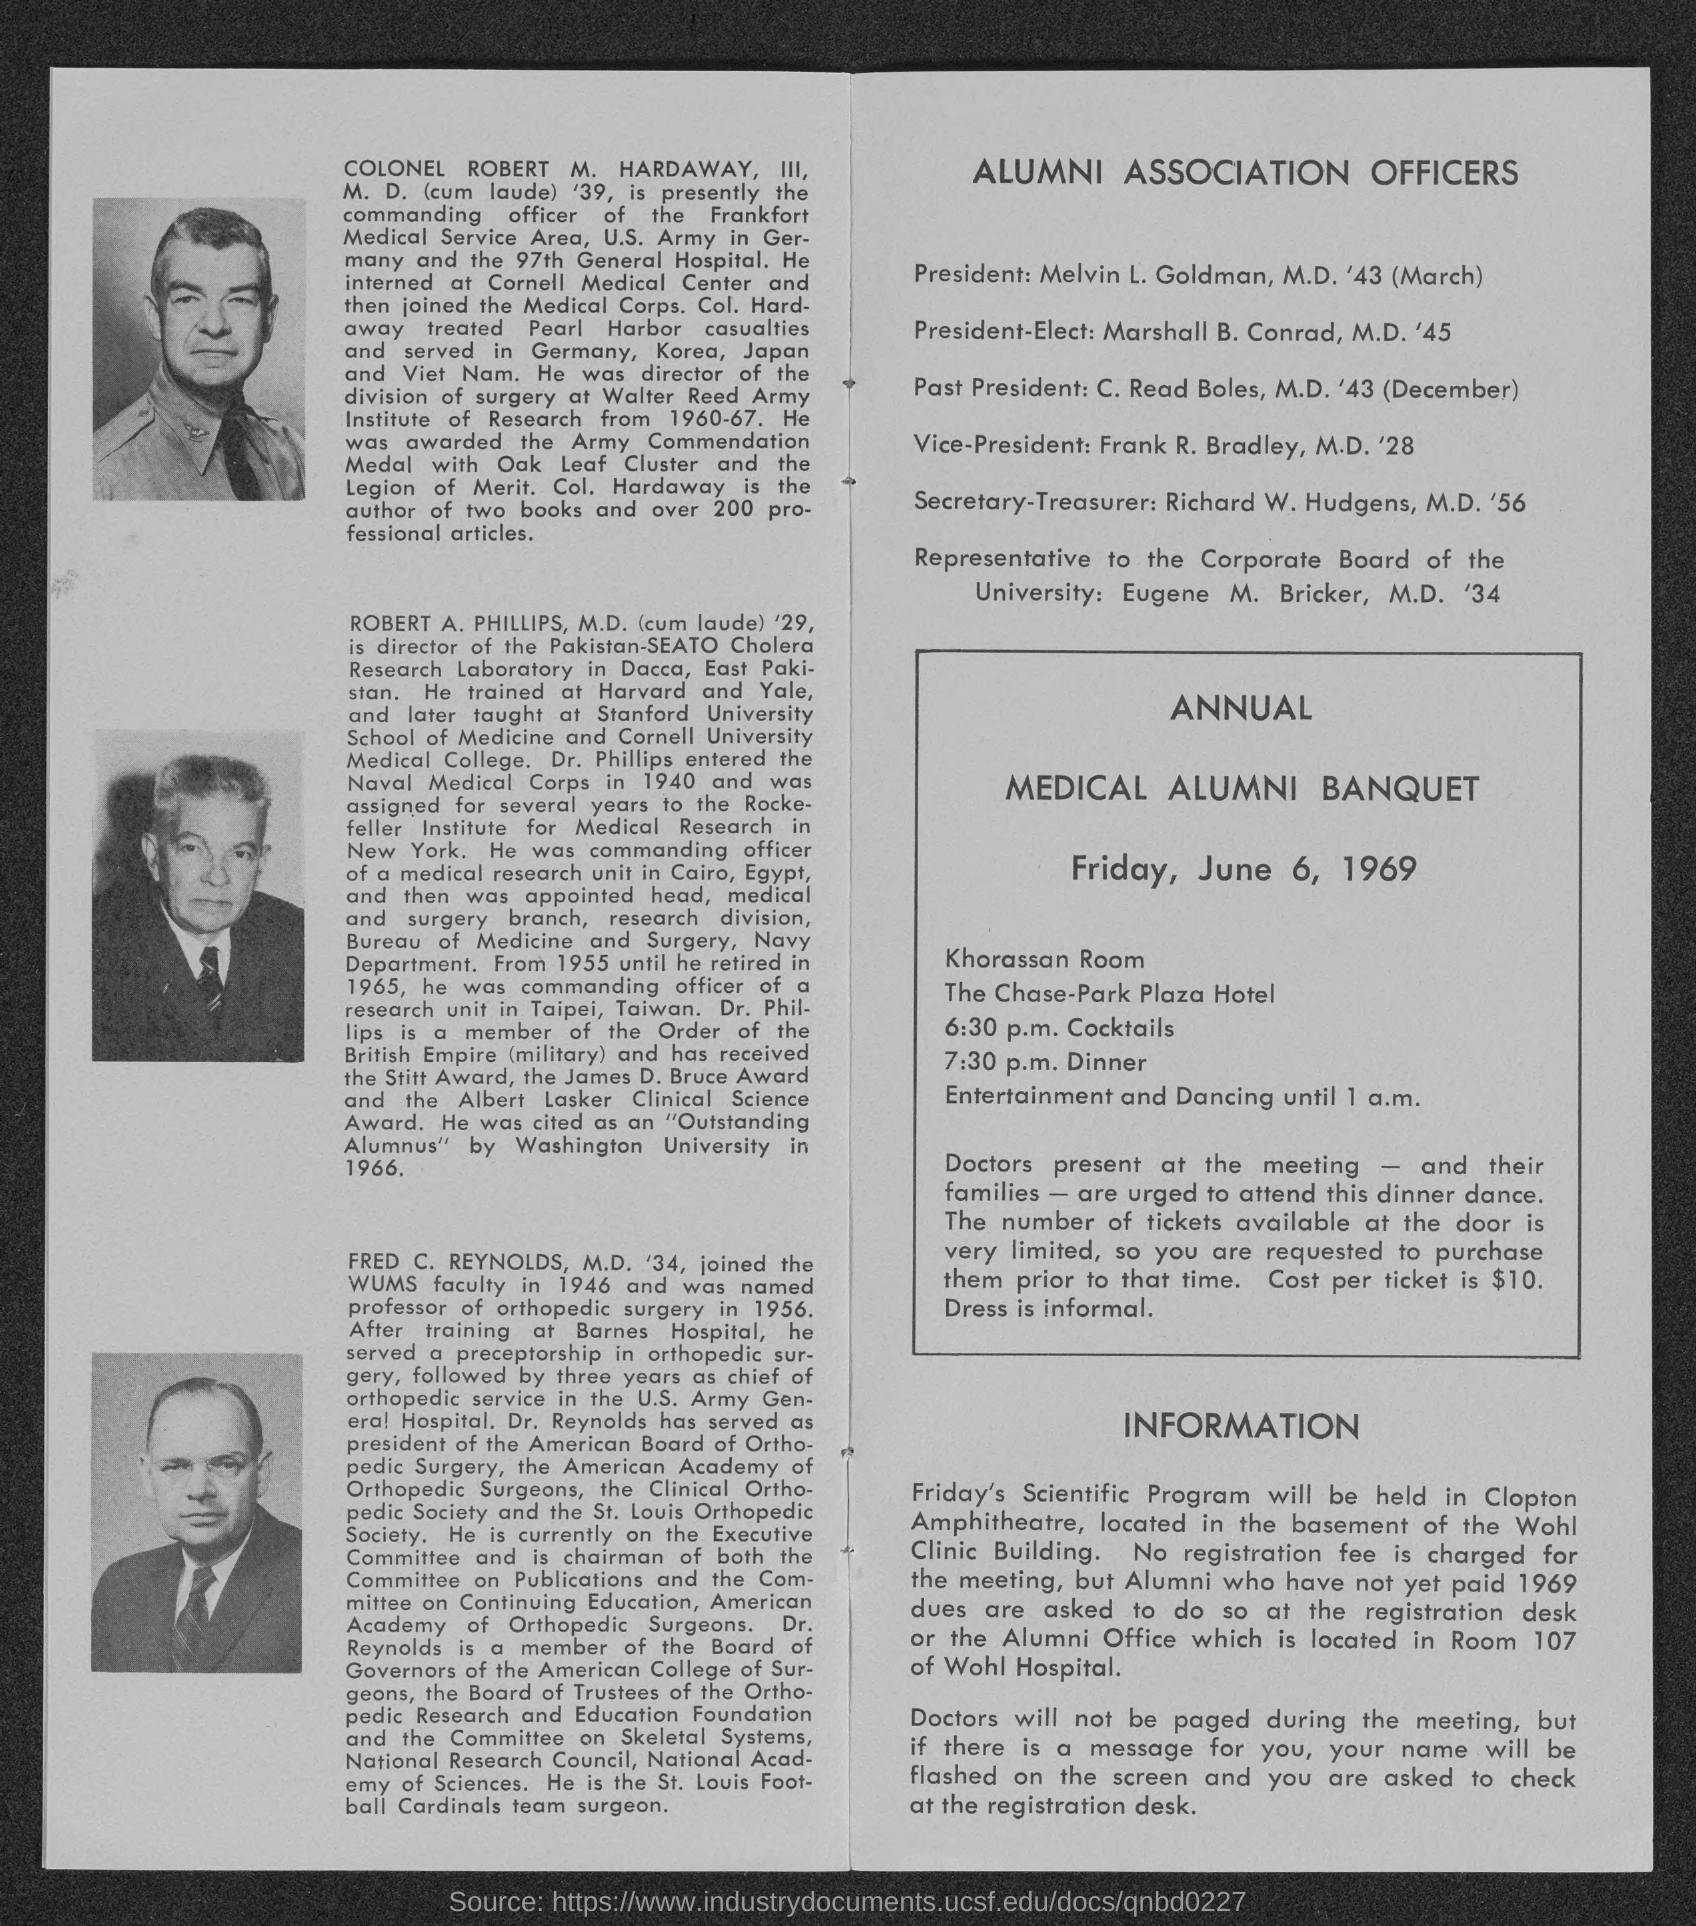What is the position of melvin l. goldman?
Keep it short and to the point. President. What is the position of marshall b. conrad ?
Ensure brevity in your answer.  President-elect. What is the position of c. read boles ?
Keep it short and to the point. Past President. What is the position of frank r. bradley ?
Ensure brevity in your answer.  Vice-president. 